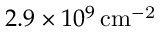<formula> <loc_0><loc_0><loc_500><loc_500>2 . 9 \times 1 0 ^ { 9 } \, { c m } ^ { - 2 }</formula> 